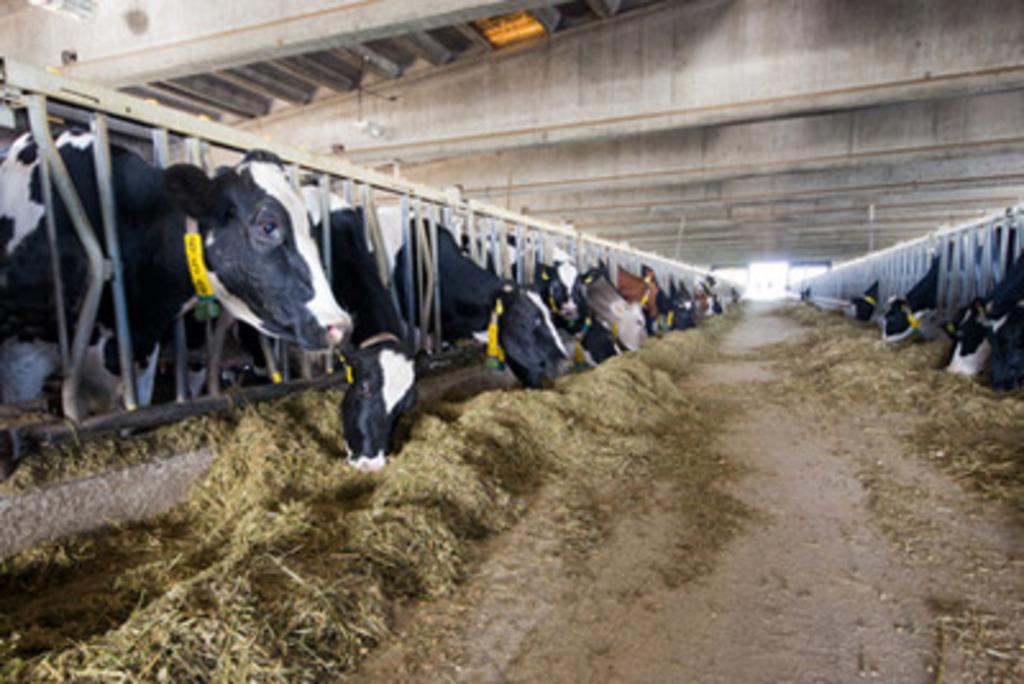How would you summarize this image in a sentence or two? In this picture I can see animals, grass and fence. 